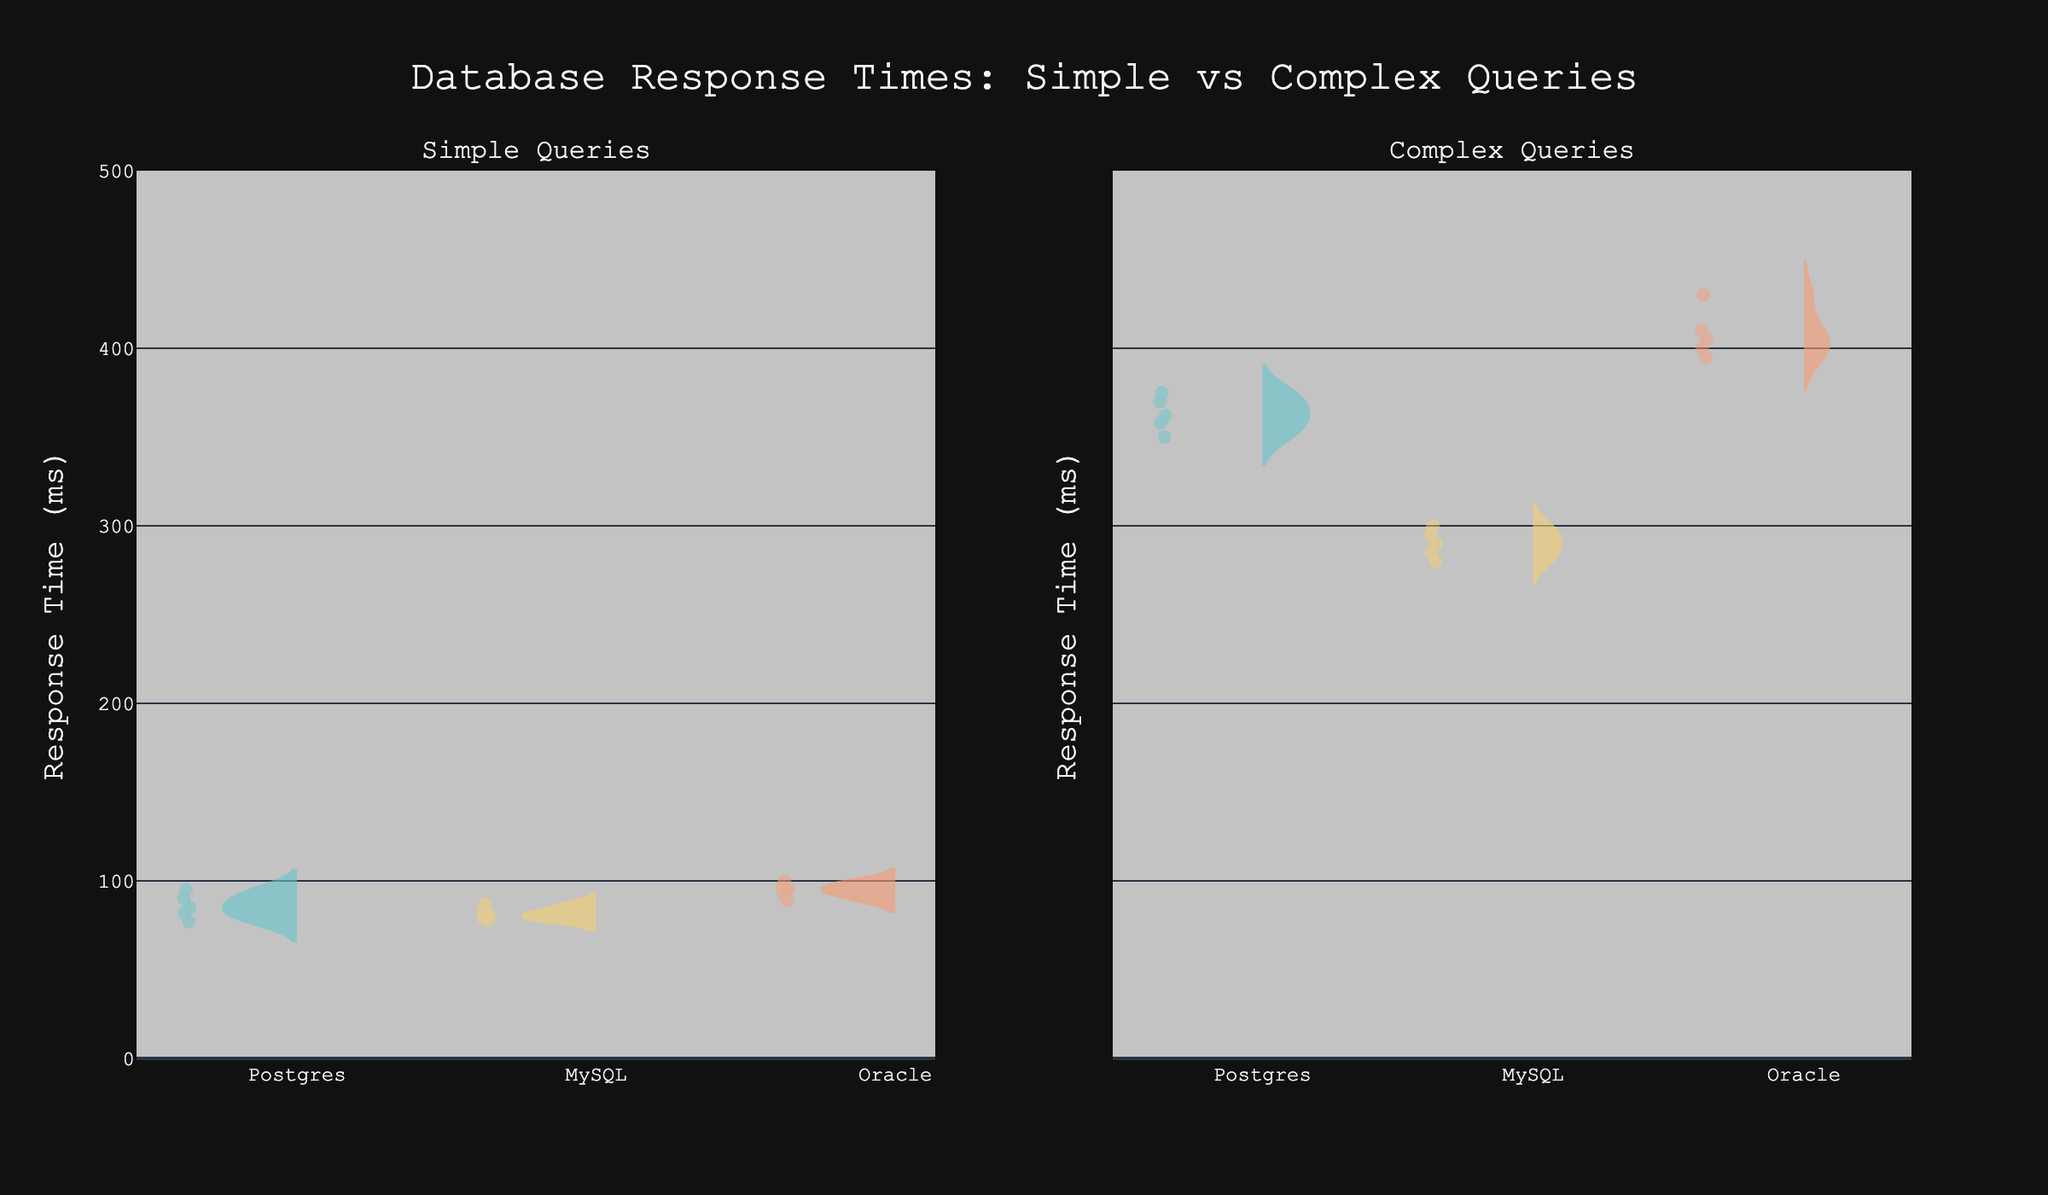What is the title of the plot? The title of the plot is located at the top and it reads: "Database Response Times: Simple vs Complex Queries".
Answer: Database Response Times: Simple vs Complex Queries How many query types are compared in the figure? The figure compares two query types, which can be identified from the subplot titles: "Simple Queries" and "Complex Queries".
Answer: Two Which database has the highest response time for complex queries and what is the value? By looking at the figure, the database with the violin plot extending highest on the y-axis in the "Complex Queries" subplot is Oracle, reaching a response time of 430 ms.
Answer: Oracle, 430 ms Compare the response times of PostgreSQL between simple and complex queries: which one is generally higher? The violin plot for PostgreSQL in the "Complex Queries" subplot generally extends higher on the y-axis compared to the "Simple Queries" subplot, indicating higher response times for complex queries.
Answer: Complex queries How does the range of response times for MySQL compare between simple and complex queries? For simple queries, the MySQL violin plot ranges approximately between 78 ms and 87 ms. For complex queries, it ranges between 280 ms and 300 ms, showing that the range for complex queries is much larger and higher.
Answer: Larger for complex queries What's the mean response time for 'Simple' Oracle queries? For the 'Simple' Oracle queries, the approximate values on the violin plot are around 95, 100, 89, 93, and 97 ms. Adding these values together gives 474, and dividing by 5 (number of data points) gives a mean of approximately 94.8 ms.
Answer: ~94.8 ms Which database has the lowest median response time for simple queries? To find the median, look at the central point of the violin plots for the "Simple Queries". MySQL appears to have its median point lower than PostgreSQL and Oracle, indicating the lowest median response time.
Answer: MySQL Do any of the databases exhibit similar response times between simple and complex queries? By observing the spread and position of the violin plots, none of the databases exhibit similar response times between simple and complex queries; all complex query response times are significantly higher.
Answer: No What is the range of response times for simple queries for PostgreSQL? The violin plot for PostgreSQL in the "Simple Queries" subplot extends from about 77 ms to 95 ms. Therefore, the range is 95-77.
Answer: 18 ms 